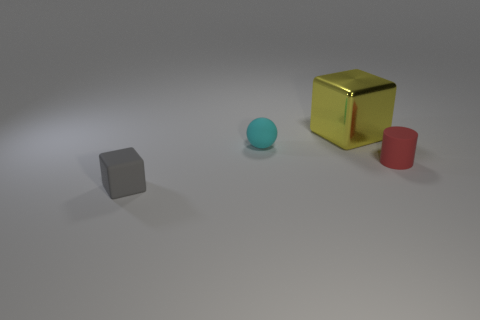Subtract all yellow cubes. How many cubes are left? 1 Subtract 1 blocks. How many blocks are left? 1 Subtract all spheres. How many objects are left? 3 Add 3 big red cylinders. How many objects exist? 7 Subtract all shiny blocks. Subtract all tiny gray things. How many objects are left? 2 Add 2 tiny matte spheres. How many tiny matte spheres are left? 3 Add 4 metal cubes. How many metal cubes exist? 5 Subtract 0 green blocks. How many objects are left? 4 Subtract all purple spheres. Subtract all red cylinders. How many spheres are left? 1 